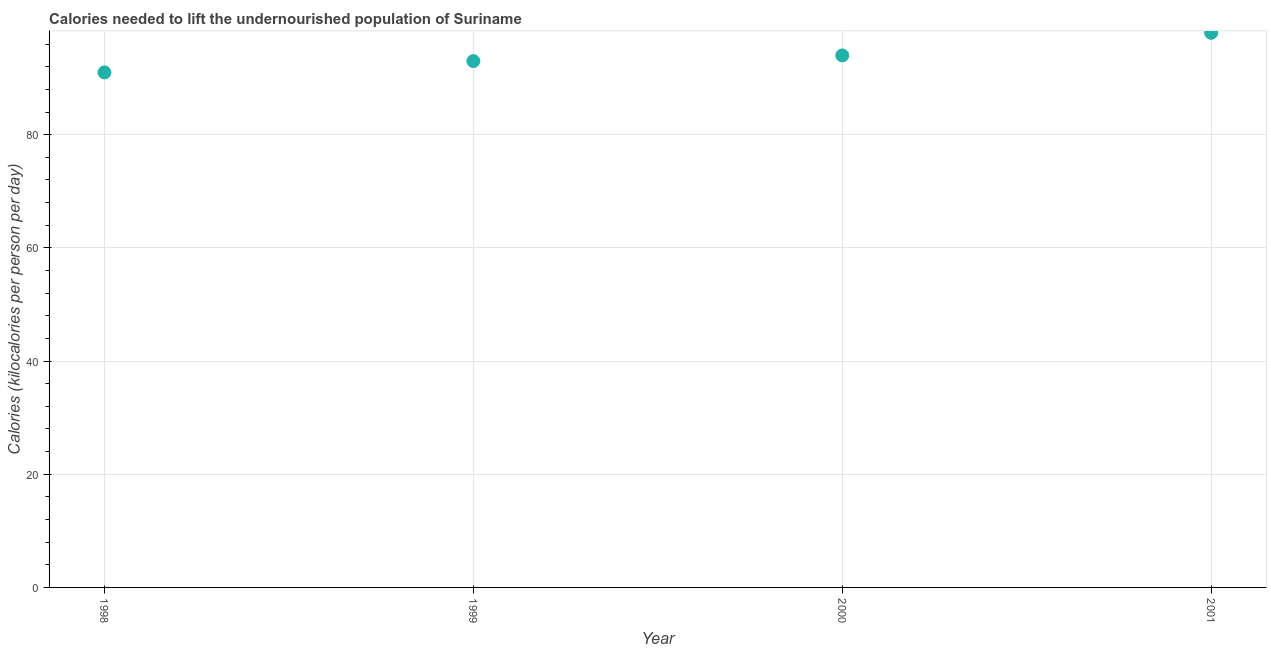What is the depth of food deficit in 2000?
Keep it short and to the point. 94. Across all years, what is the maximum depth of food deficit?
Ensure brevity in your answer.  98. Across all years, what is the minimum depth of food deficit?
Provide a succinct answer. 91. In which year was the depth of food deficit maximum?
Provide a succinct answer. 2001. What is the sum of the depth of food deficit?
Provide a succinct answer. 376. What is the difference between the depth of food deficit in 1998 and 1999?
Provide a succinct answer. -2. What is the average depth of food deficit per year?
Your answer should be very brief. 94. What is the median depth of food deficit?
Provide a succinct answer. 93.5. In how many years, is the depth of food deficit greater than 16 kilocalories?
Your answer should be very brief. 4. What is the ratio of the depth of food deficit in 1999 to that in 2000?
Your answer should be compact. 0.99. Is the depth of food deficit in 1998 less than that in 2000?
Provide a short and direct response. Yes. What is the difference between the highest and the lowest depth of food deficit?
Provide a short and direct response. 7. In how many years, is the depth of food deficit greater than the average depth of food deficit taken over all years?
Your response must be concise. 1. Does the depth of food deficit monotonically increase over the years?
Keep it short and to the point. Yes. Are the values on the major ticks of Y-axis written in scientific E-notation?
Keep it short and to the point. No. What is the title of the graph?
Offer a very short reply. Calories needed to lift the undernourished population of Suriname. What is the label or title of the X-axis?
Provide a short and direct response. Year. What is the label or title of the Y-axis?
Make the answer very short. Calories (kilocalories per person per day). What is the Calories (kilocalories per person per day) in 1998?
Give a very brief answer. 91. What is the Calories (kilocalories per person per day) in 1999?
Give a very brief answer. 93. What is the Calories (kilocalories per person per day) in 2000?
Ensure brevity in your answer.  94. What is the difference between the Calories (kilocalories per person per day) in 1998 and 2000?
Your response must be concise. -3. What is the difference between the Calories (kilocalories per person per day) in 1999 and 2000?
Your response must be concise. -1. What is the difference between the Calories (kilocalories per person per day) in 1999 and 2001?
Offer a terse response. -5. What is the difference between the Calories (kilocalories per person per day) in 2000 and 2001?
Provide a succinct answer. -4. What is the ratio of the Calories (kilocalories per person per day) in 1998 to that in 1999?
Offer a very short reply. 0.98. What is the ratio of the Calories (kilocalories per person per day) in 1998 to that in 2000?
Provide a succinct answer. 0.97. What is the ratio of the Calories (kilocalories per person per day) in 1998 to that in 2001?
Provide a short and direct response. 0.93. What is the ratio of the Calories (kilocalories per person per day) in 1999 to that in 2000?
Make the answer very short. 0.99. What is the ratio of the Calories (kilocalories per person per day) in 1999 to that in 2001?
Make the answer very short. 0.95. What is the ratio of the Calories (kilocalories per person per day) in 2000 to that in 2001?
Provide a succinct answer. 0.96. 